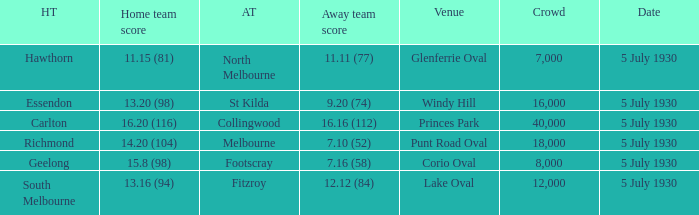I'm looking to parse the entire table for insights. Could you assist me with that? {'header': ['HT', 'Home team score', 'AT', 'Away team score', 'Venue', 'Crowd', 'Date'], 'rows': [['Hawthorn', '11.15 (81)', 'North Melbourne', '11.11 (77)', 'Glenferrie Oval', '7,000', '5 July 1930'], ['Essendon', '13.20 (98)', 'St Kilda', '9.20 (74)', 'Windy Hill', '16,000', '5 July 1930'], ['Carlton', '16.20 (116)', 'Collingwood', '16.16 (112)', 'Princes Park', '40,000', '5 July 1930'], ['Richmond', '14.20 (104)', 'Melbourne', '7.10 (52)', 'Punt Road Oval', '18,000', '5 July 1930'], ['Geelong', '15.8 (98)', 'Footscray', '7.16 (58)', 'Corio Oval', '8,000', '5 July 1930'], ['South Melbourne', '13.16 (94)', 'Fitzroy', '12.12 (84)', 'Lake Oval', '12,000', '5 July 1930']]} Who is the home team when melbourne is the away team? 14.20 (104). 